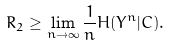<formula> <loc_0><loc_0><loc_500><loc_500>R _ { 2 } \geq \lim _ { n \to \infty } \frac { 1 } { n } H ( Y ^ { n } | C ) .</formula> 